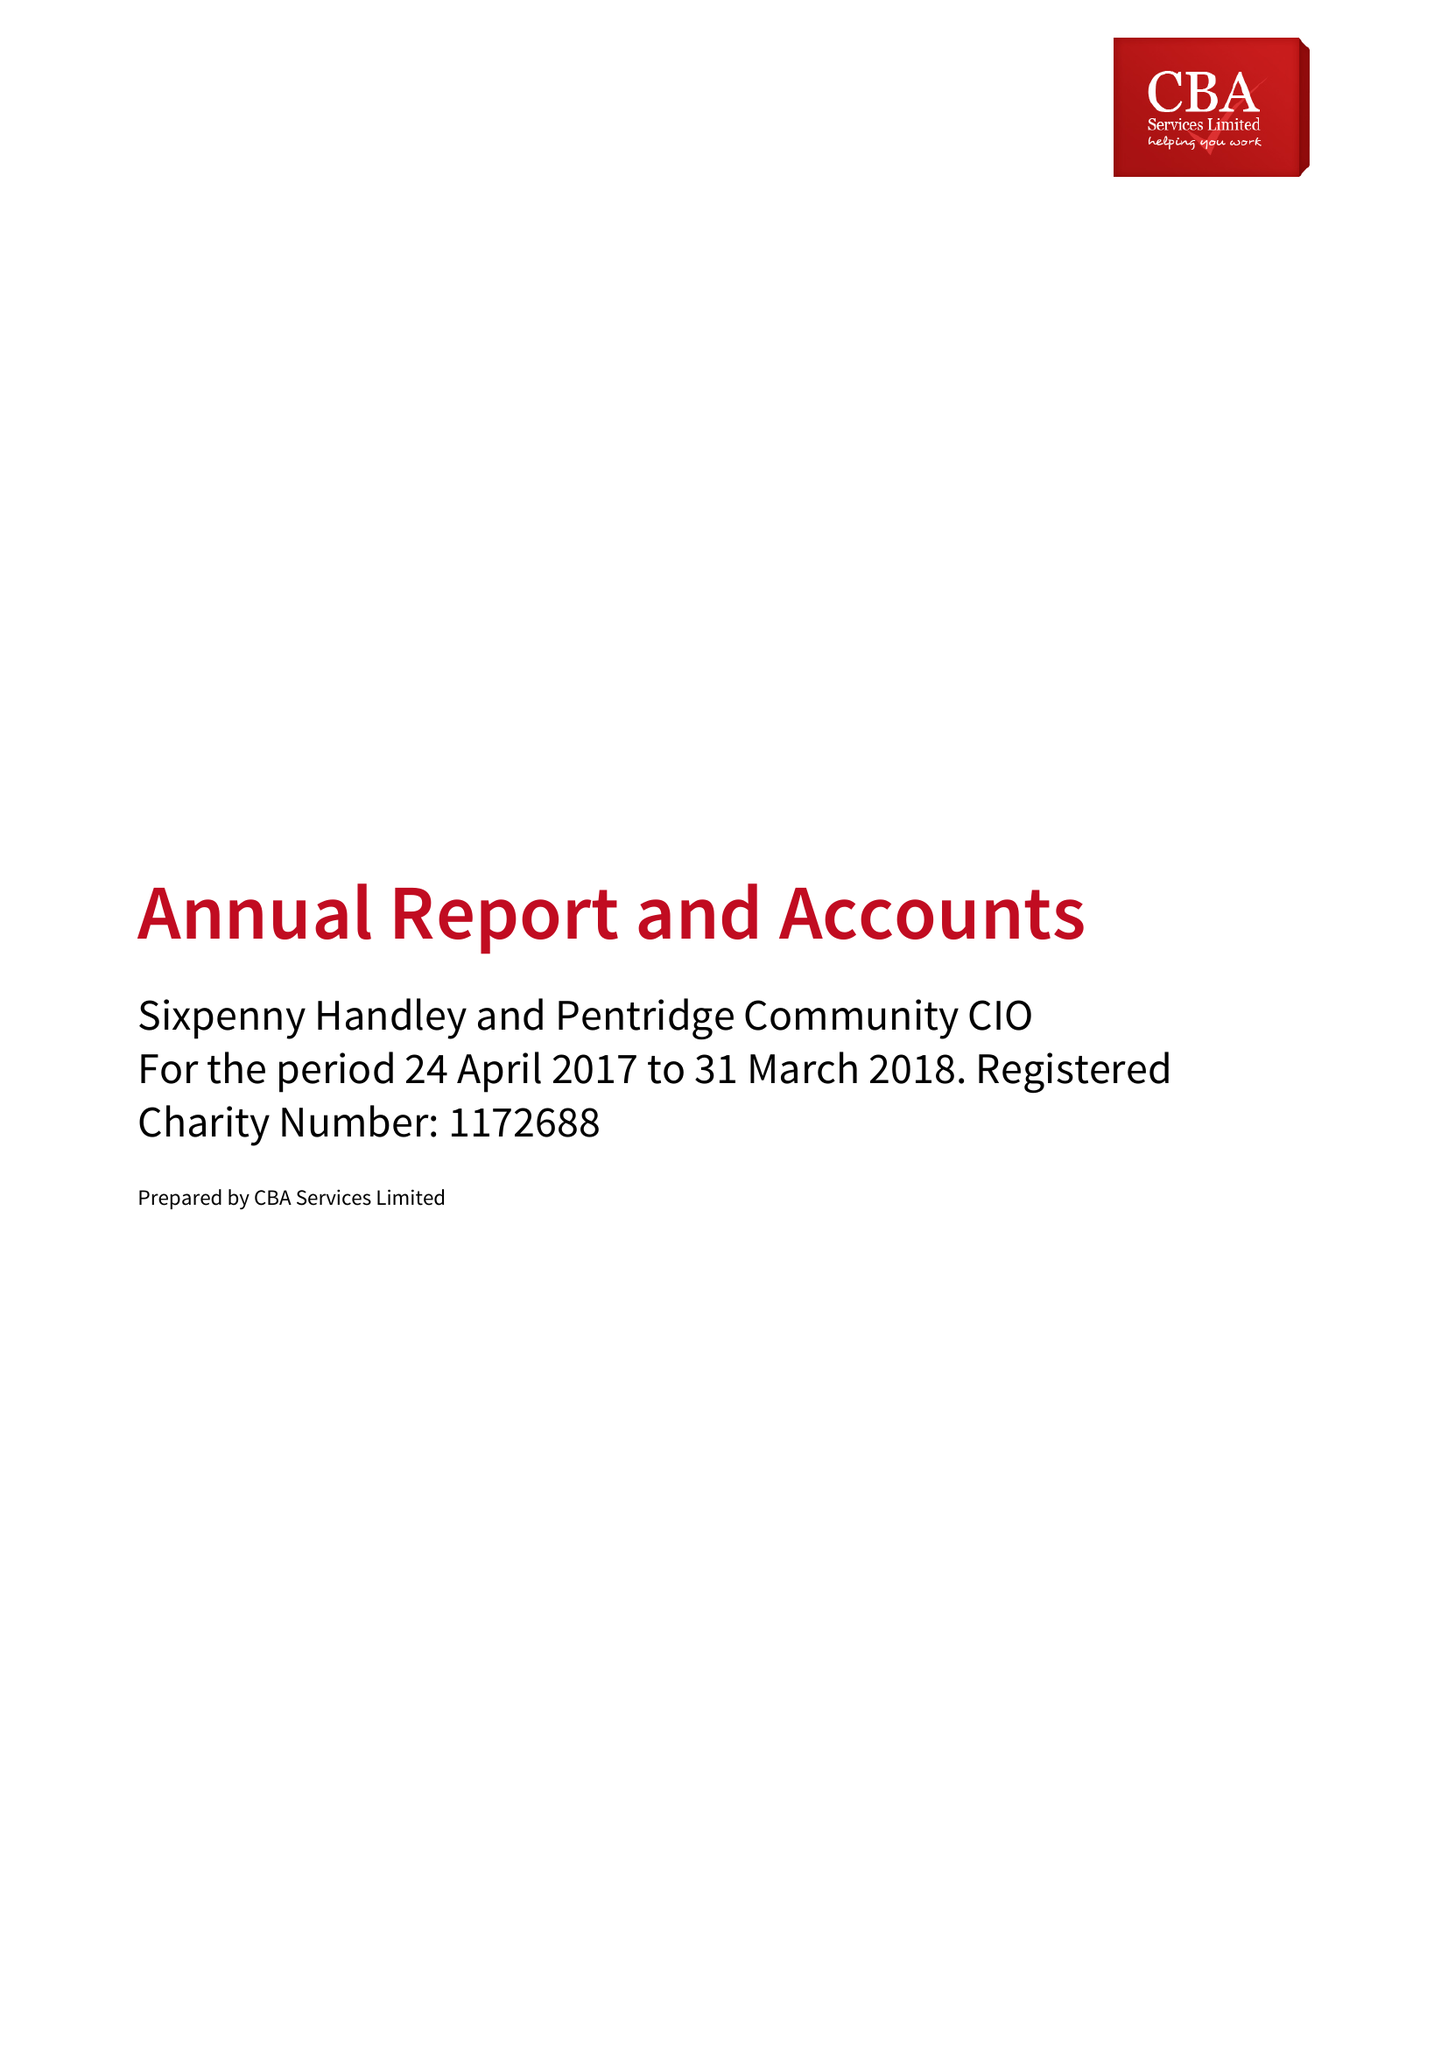What is the value for the spending_annually_in_british_pounds?
Answer the question using a single word or phrase. 5911.00 